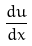<formula> <loc_0><loc_0><loc_500><loc_500>\frac { d u } { d x }</formula> 